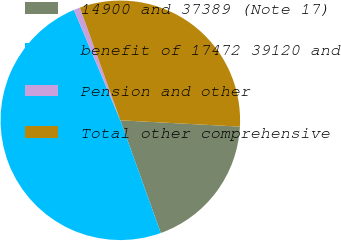Convert chart to OTSL. <chart><loc_0><loc_0><loc_500><loc_500><pie_chart><fcel>14900 and 37389 (Note 17)<fcel>benefit of 17472 39120 and<fcel>Pension and other<fcel>Total other comprehensive<nl><fcel>18.68%<fcel>49.15%<fcel>0.85%<fcel>31.32%<nl></chart> 